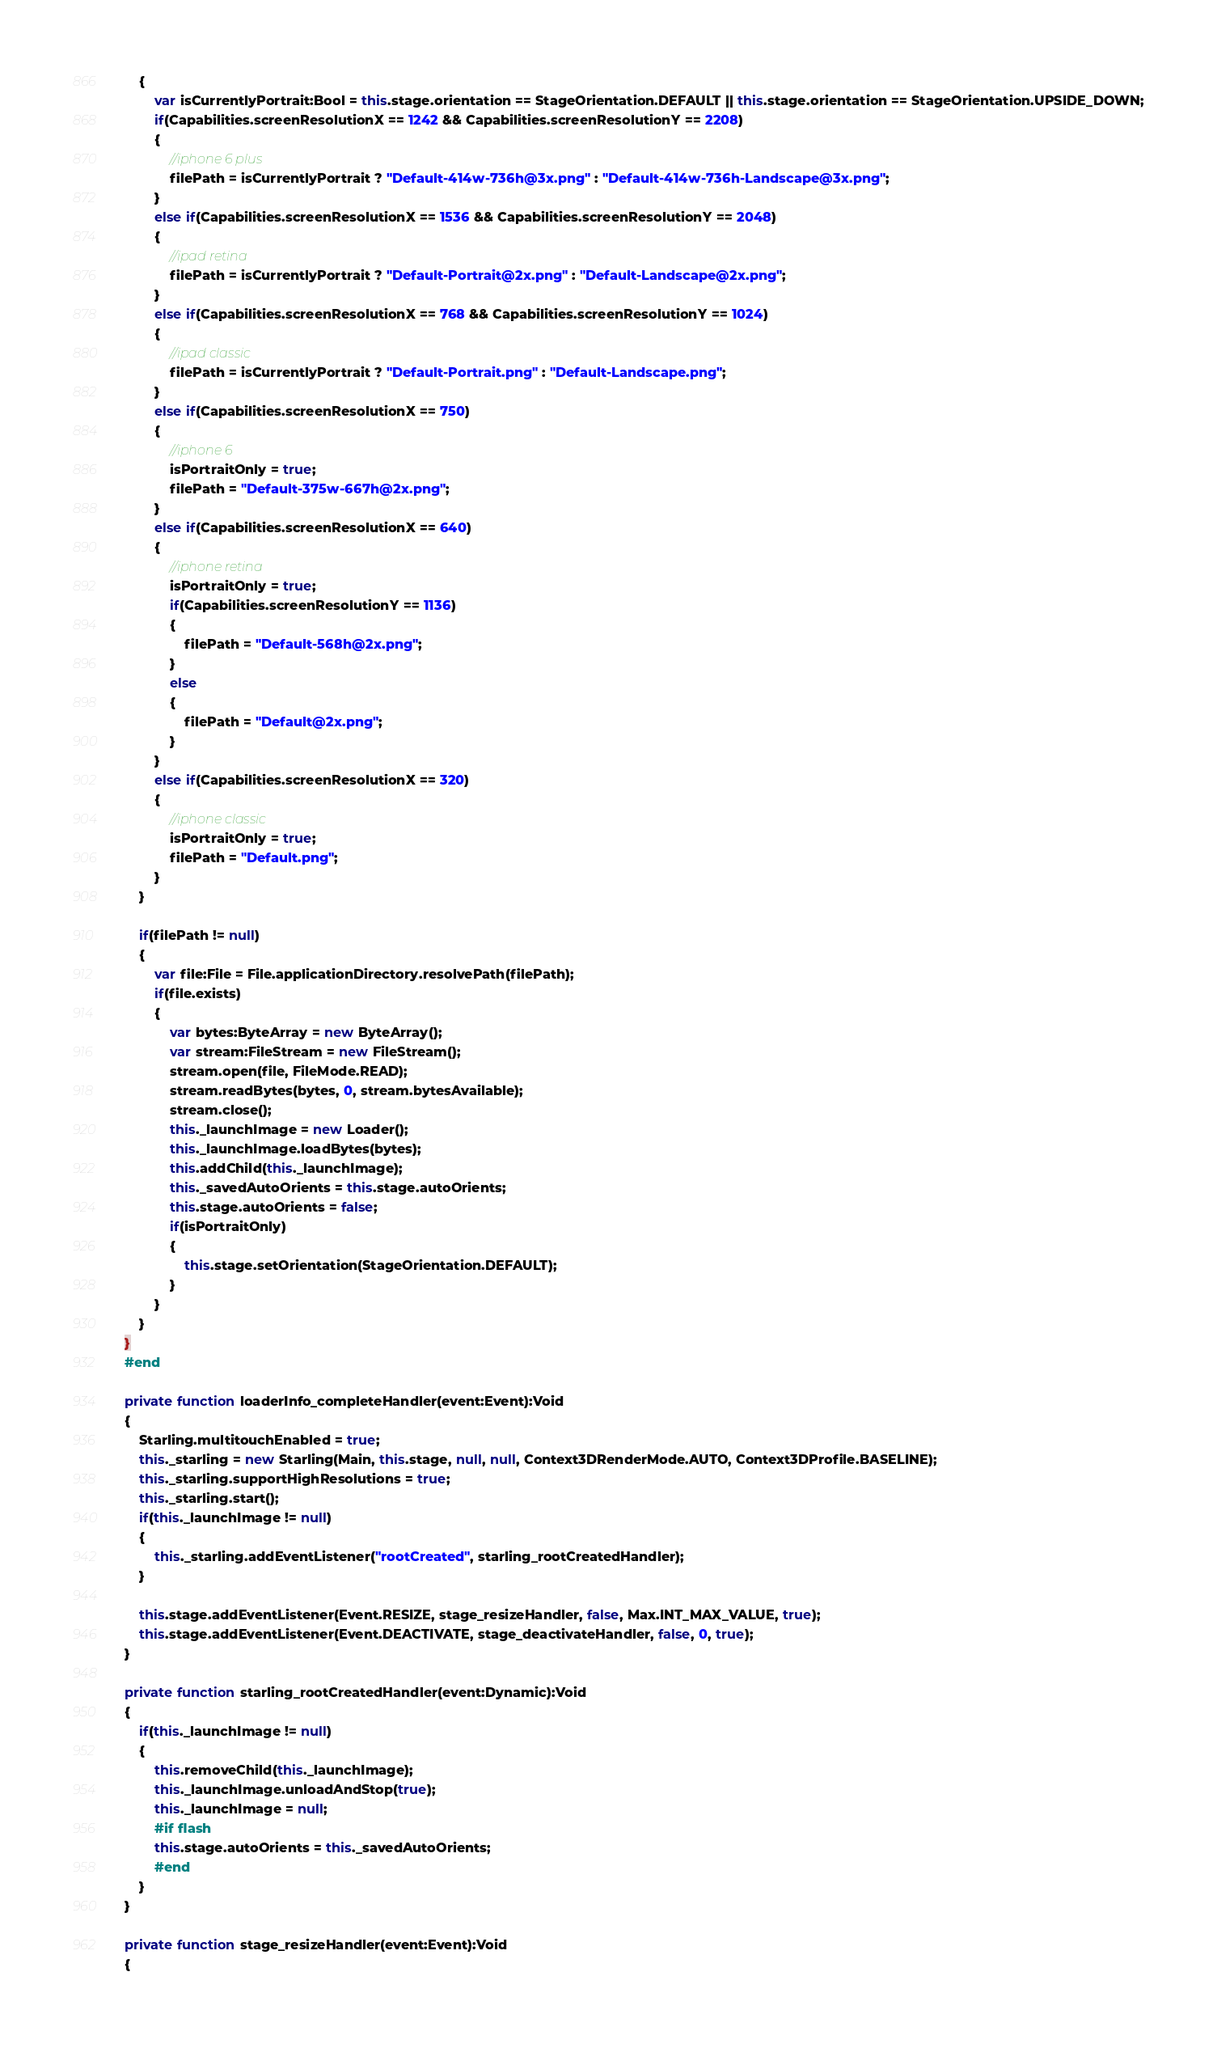Convert code to text. <code><loc_0><loc_0><loc_500><loc_500><_Haxe_>		{
			var isCurrentlyPortrait:Bool = this.stage.orientation == StageOrientation.DEFAULT || this.stage.orientation == StageOrientation.UPSIDE_DOWN;
			if(Capabilities.screenResolutionX == 1242 && Capabilities.screenResolutionY == 2208)
			{
				//iphone 6 plus
				filePath = isCurrentlyPortrait ? "Default-414w-736h@3x.png" : "Default-414w-736h-Landscape@3x.png";
			}
			else if(Capabilities.screenResolutionX == 1536 && Capabilities.screenResolutionY == 2048)
			{
				//ipad retina
				filePath = isCurrentlyPortrait ? "Default-Portrait@2x.png" : "Default-Landscape@2x.png";
			}
			else if(Capabilities.screenResolutionX == 768 && Capabilities.screenResolutionY == 1024)
			{
				//ipad classic
				filePath = isCurrentlyPortrait ? "Default-Portrait.png" : "Default-Landscape.png";
			}
			else if(Capabilities.screenResolutionX == 750)
			{
				//iphone 6
				isPortraitOnly = true;
				filePath = "Default-375w-667h@2x.png";
			}
			else if(Capabilities.screenResolutionX == 640)
			{
				//iphone retina
				isPortraitOnly = true;
				if(Capabilities.screenResolutionY == 1136)
				{
					filePath = "Default-568h@2x.png";
				}
				else
				{
					filePath = "Default@2x.png";
				}
			}
			else if(Capabilities.screenResolutionX == 320)
			{
				//iphone classic
				isPortraitOnly = true;
				filePath = "Default.png";
			}
		}

		if(filePath != null)
		{
			var file:File = File.applicationDirectory.resolvePath(filePath);
			if(file.exists)
			{
				var bytes:ByteArray = new ByteArray();
				var stream:FileStream = new FileStream();
				stream.open(file, FileMode.READ);
				stream.readBytes(bytes, 0, stream.bytesAvailable);
				stream.close();
				this._launchImage = new Loader();
				this._launchImage.loadBytes(bytes);
				this.addChild(this._launchImage);
				this._savedAutoOrients = this.stage.autoOrients;
				this.stage.autoOrients = false;
				if(isPortraitOnly)
				{
					this.stage.setOrientation(StageOrientation.DEFAULT);
				}
			}
		}
	}
	#end

	private function loaderInfo_completeHandler(event:Event):Void
	{
		Starling.multitouchEnabled = true;
		this._starling = new Starling(Main, this.stage, null, null, Context3DRenderMode.AUTO, Context3DProfile.BASELINE);
		this._starling.supportHighResolutions = true;
		this._starling.start();
		if(this._launchImage != null)
		{
			this._starling.addEventListener("rootCreated", starling_rootCreatedHandler);
		}

		this.stage.addEventListener(Event.RESIZE, stage_resizeHandler, false, Max.INT_MAX_VALUE, true);
		this.stage.addEventListener(Event.DEACTIVATE, stage_deactivateHandler, false, 0, true);
	}

	private function starling_rootCreatedHandler(event:Dynamic):Void
	{
		if(this._launchImage != null)
		{
			this.removeChild(this._launchImage);
			this._launchImage.unloadAndStop(true);
			this._launchImage = null;
			#if flash
			this.stage.autoOrients = this._savedAutoOrients;
			#end
		}
	}

	private function stage_resizeHandler(event:Event):Void
	{</code> 